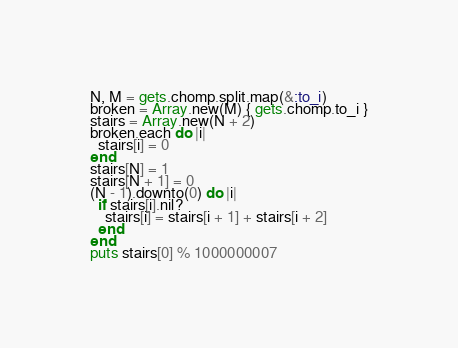<code> <loc_0><loc_0><loc_500><loc_500><_Ruby_>N, M = gets.chomp.split.map(&:to_i)
broken = Array.new(M) { gets.chomp.to_i }
stairs = Array.new(N + 2)
broken.each do |i|
  stairs[i] = 0
end
stairs[N] = 1
stairs[N + 1] = 0
(N - 1).downto(0) do |i|
  if stairs[i].nil?
    stairs[i] = stairs[i + 1] + stairs[i + 2]
  end
end
puts stairs[0] % 1000000007
</code> 